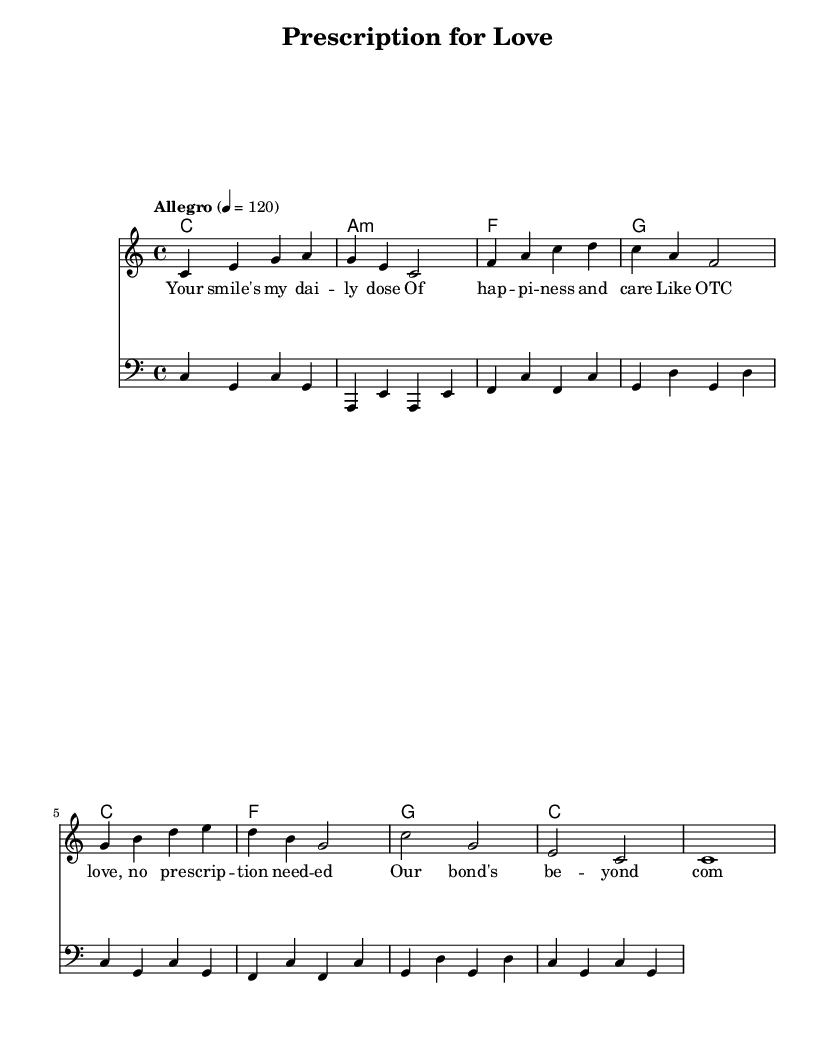What is the key signature of this music? The key signature is indicated at the beginning of the staff, showing that it is in C major, which has no sharps or flats.
Answer: C major What is the time signature of this piece? The time signature is located at the beginning of the score and is presented as 4/4, meaning there are four beats per measure and the quarter note gets one beat.
Answer: 4/4 What is the tempo marking of this piece? The tempo marking is found above the staff and indicates that the piece should be played at a speed of 120 beats per minute, indicated as "Allegro."
Answer: Allegro What is the last note of the melody? To find the last note of the melody, look at the final measure of the melody staff, which shows the note C held out for the entire measure, indicating it is a whole note.
Answer: C How many chords are used in total throughout this piece? Counting the chords indicated in the chordnames staff, there are 8 unique chord changes visible across the measures shown during the sequence of the song.
Answer: 8 What is the significance of the lyrics in relation to the pharmaceutical theme in the song? The lyrics reference common pharmaceutical terms such as "daily dose" and "OTC," indicating a playful integration of medication terminology into expressions of love, suggesting a connection between caring and medicine.
Answer: Subtle reference What type of music is this piece classified as? Given the upbeat tempo, structured lyrics, and catchy melody, this piece fits into the Pop category, which is characterized by its accessibility and broad appeal.
Answer: Pop 